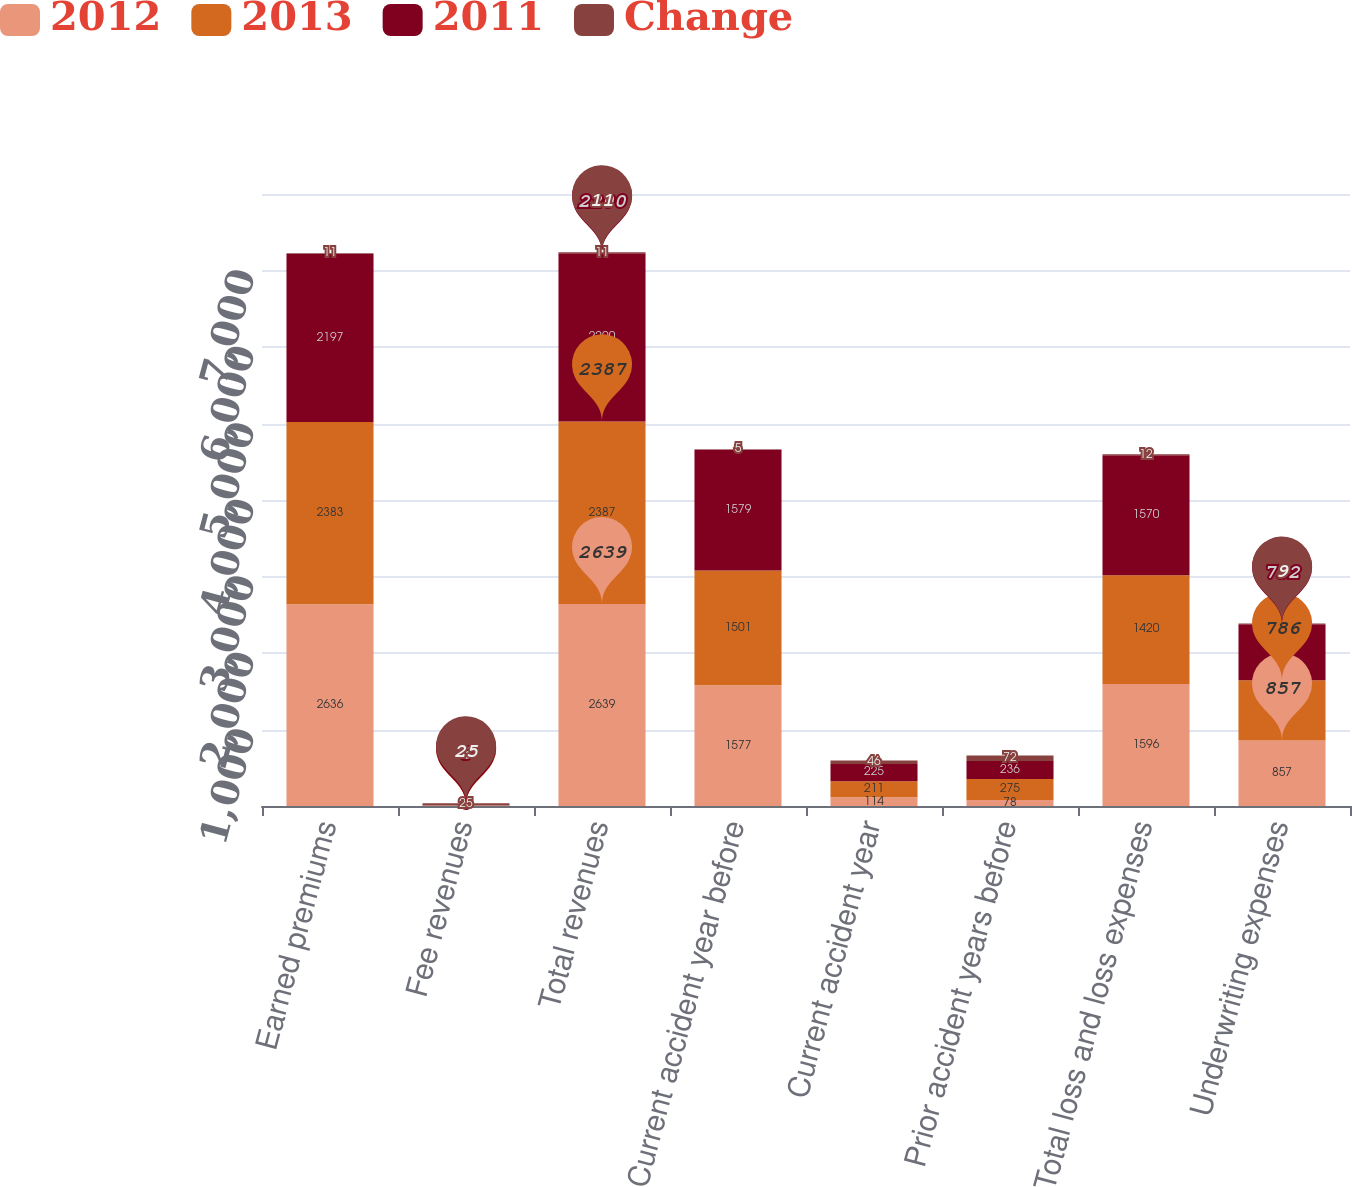Convert chart to OTSL. <chart><loc_0><loc_0><loc_500><loc_500><stacked_bar_chart><ecel><fcel>Earned premiums<fcel>Fee revenues<fcel>Total revenues<fcel>Current accident year before<fcel>Current accident year<fcel>Prior accident years before<fcel>Total loss and loss expenses<fcel>Underwriting expenses<nl><fcel>2012<fcel>2636<fcel>3<fcel>2639<fcel>1577<fcel>114<fcel>78<fcel>1596<fcel>857<nl><fcel>2013<fcel>2383<fcel>4<fcel>2387<fcel>1501<fcel>211<fcel>275<fcel>1420<fcel>786<nl><fcel>2011<fcel>2197<fcel>3<fcel>2200<fcel>1579<fcel>225<fcel>236<fcel>1570<fcel>732<nl><fcel>Change<fcel>11<fcel>25<fcel>11<fcel>5<fcel>46<fcel>72<fcel>12<fcel>9<nl></chart> 